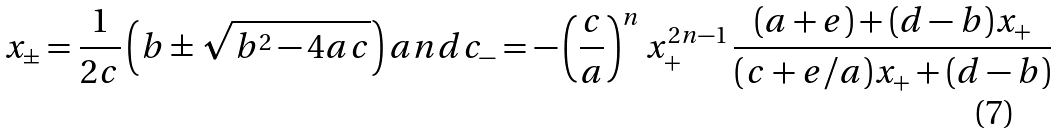<formula> <loc_0><loc_0><loc_500><loc_500>x _ { \pm } = \frac { 1 } { 2 c } \left ( b \pm \sqrt { b ^ { 2 } - 4 a c } \right ) a n d c _ { - } = - \left ( \frac { c } { a } \right ) ^ { n } x _ { + } ^ { 2 n - 1 } \, \frac { ( a + e ) + ( d - b ) x _ { + } } { ( c + e / a ) x _ { + } + ( d - b ) }</formula> 